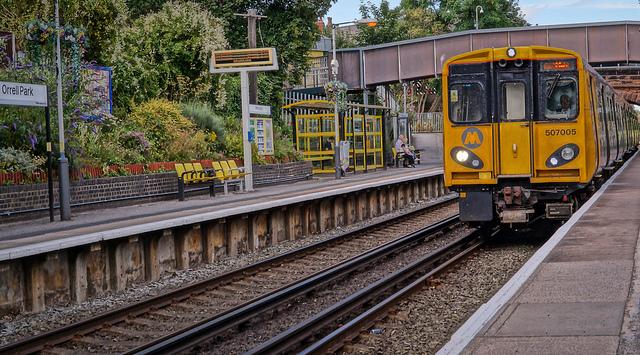What color is this train?
Quick response, please. Yellow. How many train tracks do you see?
Quick response, please. 2. Why are the lights on?
Give a very brief answer. Safety. Can cars go over the bridge?
Quick response, please. No. Is the train arriving or departing?
Give a very brief answer. Departing. How many trains are in the image?
Be succinct. 1. 